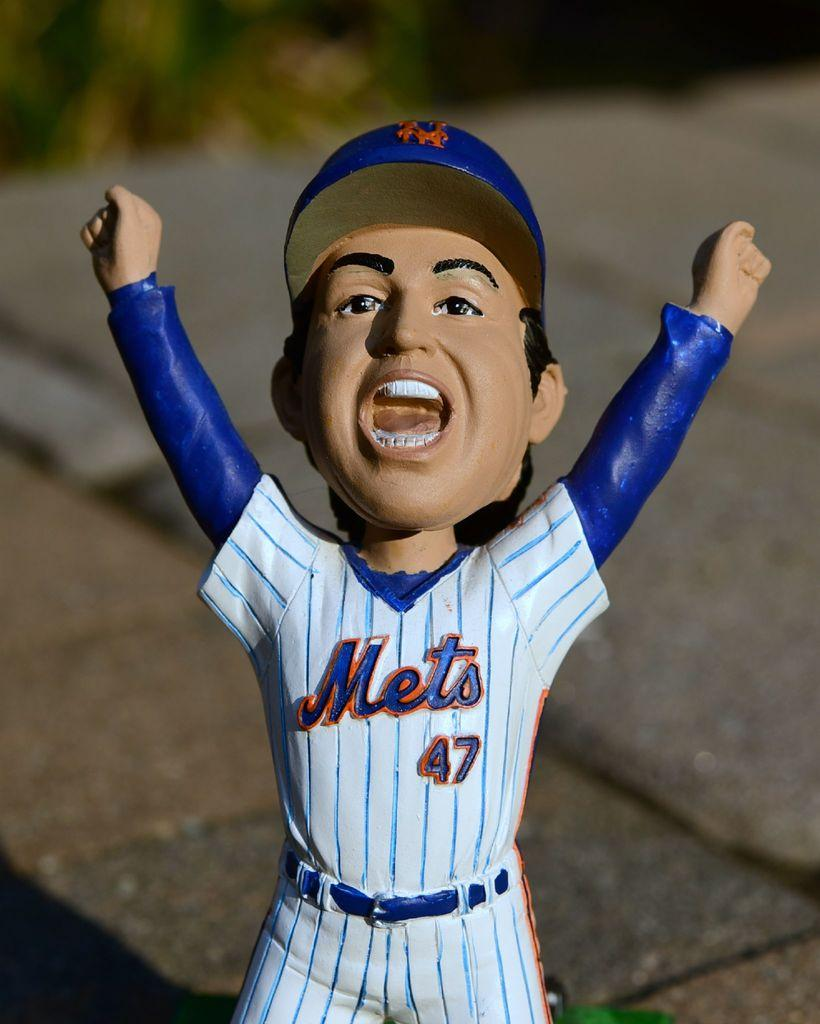Provide a one-sentence caption for the provided image. A Mets player #47 bobble head figure is shown with his hands up and mouth open. 